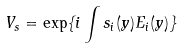Convert formula to latex. <formula><loc_0><loc_0><loc_500><loc_500>V _ { s } = \exp \{ i \int s _ { i } ( y ) E _ { i } ( y ) \}</formula> 